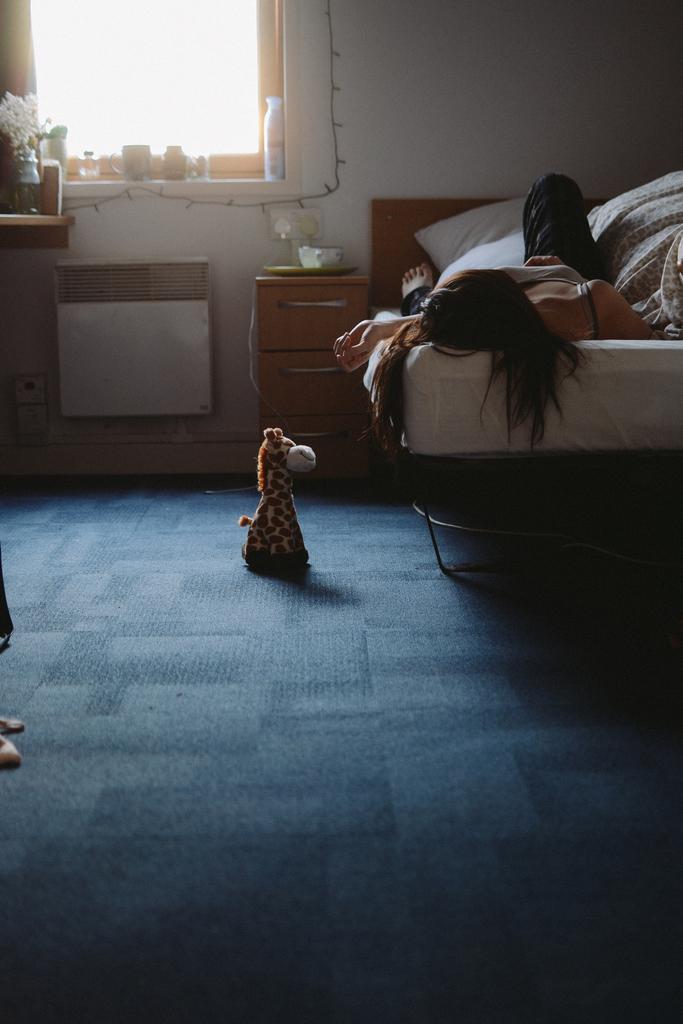Describe this image in one or two sentences. In this picture a woman is lying on the bed, here is the pillow, and here is the window and flower vase on the table, and the toy on the floor. 